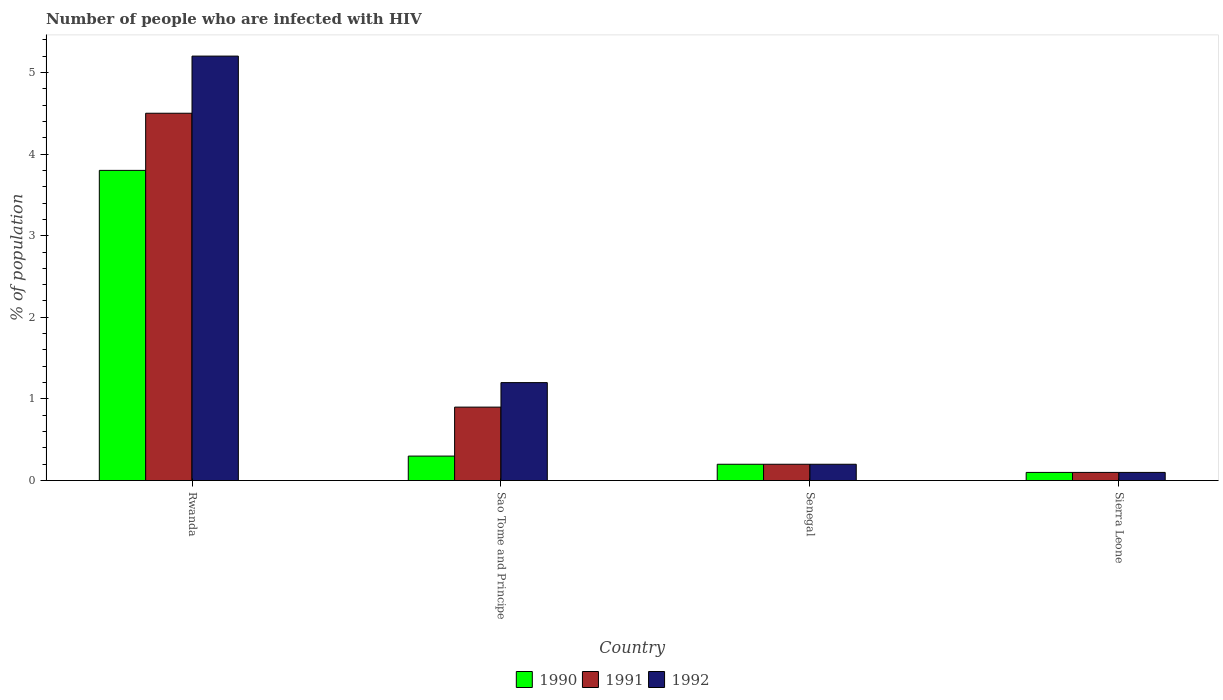How many different coloured bars are there?
Your answer should be very brief. 3. What is the label of the 3rd group of bars from the left?
Offer a terse response. Senegal. In how many cases, is the number of bars for a given country not equal to the number of legend labels?
Make the answer very short. 0. What is the percentage of HIV infected population in in 1990 in Rwanda?
Provide a succinct answer. 3.8. Across all countries, what is the maximum percentage of HIV infected population in in 1991?
Make the answer very short. 4.5. Across all countries, what is the minimum percentage of HIV infected population in in 1992?
Give a very brief answer. 0.1. In which country was the percentage of HIV infected population in in 1992 maximum?
Provide a short and direct response. Rwanda. In which country was the percentage of HIV infected population in in 1991 minimum?
Offer a terse response. Sierra Leone. What is the difference between the percentage of HIV infected population in in 1991 in Rwanda and that in Sao Tome and Principe?
Your response must be concise. 3.6. What is the difference between the percentage of HIV infected population in in 1991 in Sierra Leone and the percentage of HIV infected population in in 1990 in Sao Tome and Principe?
Your answer should be very brief. -0.2. What is the average percentage of HIV infected population in in 1992 per country?
Provide a succinct answer. 1.68. What is the difference between the percentage of HIV infected population in of/in 1990 and percentage of HIV infected population in of/in 1992 in Rwanda?
Your answer should be very brief. -1.4. What is the difference between the highest and the lowest percentage of HIV infected population in in 1990?
Your answer should be very brief. 3.7. Is the sum of the percentage of HIV infected population in in 1991 in Rwanda and Sierra Leone greater than the maximum percentage of HIV infected population in in 1990 across all countries?
Your answer should be very brief. Yes. How many bars are there?
Keep it short and to the point. 12. Are all the bars in the graph horizontal?
Provide a short and direct response. No. Does the graph contain grids?
Give a very brief answer. No. How many legend labels are there?
Your response must be concise. 3. What is the title of the graph?
Provide a short and direct response. Number of people who are infected with HIV. Does "1974" appear as one of the legend labels in the graph?
Provide a succinct answer. No. What is the label or title of the Y-axis?
Make the answer very short. % of population. What is the % of population of 1991 in Sao Tome and Principe?
Provide a short and direct response. 0.9. What is the % of population of 1991 in Senegal?
Give a very brief answer. 0.2. What is the % of population in 1992 in Sierra Leone?
Make the answer very short. 0.1. Across all countries, what is the maximum % of population in 1991?
Your answer should be very brief. 4.5. Across all countries, what is the minimum % of population in 1991?
Provide a succinct answer. 0.1. Across all countries, what is the minimum % of population in 1992?
Your answer should be very brief. 0.1. What is the total % of population of 1990 in the graph?
Offer a very short reply. 4.4. What is the total % of population of 1991 in the graph?
Make the answer very short. 5.7. What is the total % of population in 1992 in the graph?
Keep it short and to the point. 6.7. What is the difference between the % of population of 1990 in Rwanda and that in Sao Tome and Principe?
Make the answer very short. 3.5. What is the difference between the % of population of 1991 in Rwanda and that in Sao Tome and Principe?
Your response must be concise. 3.6. What is the difference between the % of population in 1992 in Rwanda and that in Sao Tome and Principe?
Ensure brevity in your answer.  4. What is the difference between the % of population in 1992 in Rwanda and that in Senegal?
Provide a short and direct response. 5. What is the difference between the % of population of 1991 in Rwanda and that in Sierra Leone?
Offer a terse response. 4.4. What is the difference between the % of population in 1991 in Sao Tome and Principe and that in Senegal?
Your response must be concise. 0.7. What is the difference between the % of population of 1990 in Sao Tome and Principe and that in Sierra Leone?
Your response must be concise. 0.2. What is the difference between the % of population of 1992 in Sao Tome and Principe and that in Sierra Leone?
Your answer should be compact. 1.1. What is the difference between the % of population of 1992 in Senegal and that in Sierra Leone?
Provide a short and direct response. 0.1. What is the difference between the % of population in 1990 in Rwanda and the % of population in 1992 in Sao Tome and Principe?
Offer a terse response. 2.6. What is the difference between the % of population of 1991 in Rwanda and the % of population of 1992 in Senegal?
Your answer should be compact. 4.3. What is the difference between the % of population in 1990 in Rwanda and the % of population in 1991 in Sierra Leone?
Ensure brevity in your answer.  3.7. What is the difference between the % of population of 1990 in Rwanda and the % of population of 1992 in Sierra Leone?
Provide a short and direct response. 3.7. What is the difference between the % of population in 1991 in Rwanda and the % of population in 1992 in Sierra Leone?
Your answer should be compact. 4.4. What is the difference between the % of population in 1990 in Sao Tome and Principe and the % of population in 1992 in Senegal?
Your response must be concise. 0.1. What is the difference between the % of population in 1990 in Sao Tome and Principe and the % of population in 1991 in Sierra Leone?
Your answer should be very brief. 0.2. What is the difference between the % of population of 1990 in Sao Tome and Principe and the % of population of 1992 in Sierra Leone?
Your response must be concise. 0.2. What is the difference between the % of population in 1991 in Sao Tome and Principe and the % of population in 1992 in Sierra Leone?
Offer a very short reply. 0.8. What is the difference between the % of population in 1990 in Senegal and the % of population in 1992 in Sierra Leone?
Make the answer very short. 0.1. What is the average % of population of 1990 per country?
Offer a very short reply. 1.1. What is the average % of population of 1991 per country?
Ensure brevity in your answer.  1.43. What is the average % of population of 1992 per country?
Your answer should be compact. 1.68. What is the difference between the % of population in 1990 and % of population in 1992 in Rwanda?
Provide a short and direct response. -1.4. What is the difference between the % of population in 1990 and % of population in 1992 in Sao Tome and Principe?
Give a very brief answer. -0.9. What is the difference between the % of population in 1991 and % of population in 1992 in Sao Tome and Principe?
Provide a short and direct response. -0.3. What is the difference between the % of population in 1990 and % of population in 1991 in Senegal?
Your answer should be very brief. 0. What is the difference between the % of population of 1991 and % of population of 1992 in Senegal?
Provide a short and direct response. 0. What is the difference between the % of population in 1991 and % of population in 1992 in Sierra Leone?
Make the answer very short. 0. What is the ratio of the % of population in 1990 in Rwanda to that in Sao Tome and Principe?
Make the answer very short. 12.67. What is the ratio of the % of population in 1991 in Rwanda to that in Sao Tome and Principe?
Offer a terse response. 5. What is the ratio of the % of population in 1992 in Rwanda to that in Sao Tome and Principe?
Provide a short and direct response. 4.33. What is the ratio of the % of population of 1992 in Rwanda to that in Senegal?
Make the answer very short. 26. What is the ratio of the % of population of 1990 in Rwanda to that in Sierra Leone?
Your answer should be very brief. 38. What is the ratio of the % of population of 1991 in Rwanda to that in Sierra Leone?
Offer a terse response. 45. What is the ratio of the % of population of 1992 in Rwanda to that in Sierra Leone?
Your answer should be very brief. 52. What is the ratio of the % of population of 1990 in Sao Tome and Principe to that in Senegal?
Offer a very short reply. 1.5. What is the ratio of the % of population in 1990 in Sao Tome and Principe to that in Sierra Leone?
Provide a succinct answer. 3. What is the ratio of the % of population of 1992 in Sao Tome and Principe to that in Sierra Leone?
Make the answer very short. 12. What is the ratio of the % of population of 1990 in Senegal to that in Sierra Leone?
Your answer should be very brief. 2. What is the ratio of the % of population in 1991 in Senegal to that in Sierra Leone?
Ensure brevity in your answer.  2. What is the difference between the highest and the second highest % of population of 1991?
Offer a very short reply. 3.6. What is the difference between the highest and the second highest % of population in 1992?
Offer a terse response. 4. What is the difference between the highest and the lowest % of population of 1990?
Your answer should be compact. 3.7. What is the difference between the highest and the lowest % of population in 1992?
Ensure brevity in your answer.  5.1. 